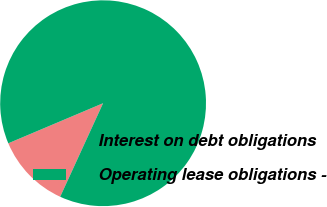Convert chart to OTSL. <chart><loc_0><loc_0><loc_500><loc_500><pie_chart><fcel>Interest on debt obligations<fcel>Operating lease obligations -<nl><fcel>11.79%<fcel>88.21%<nl></chart> 